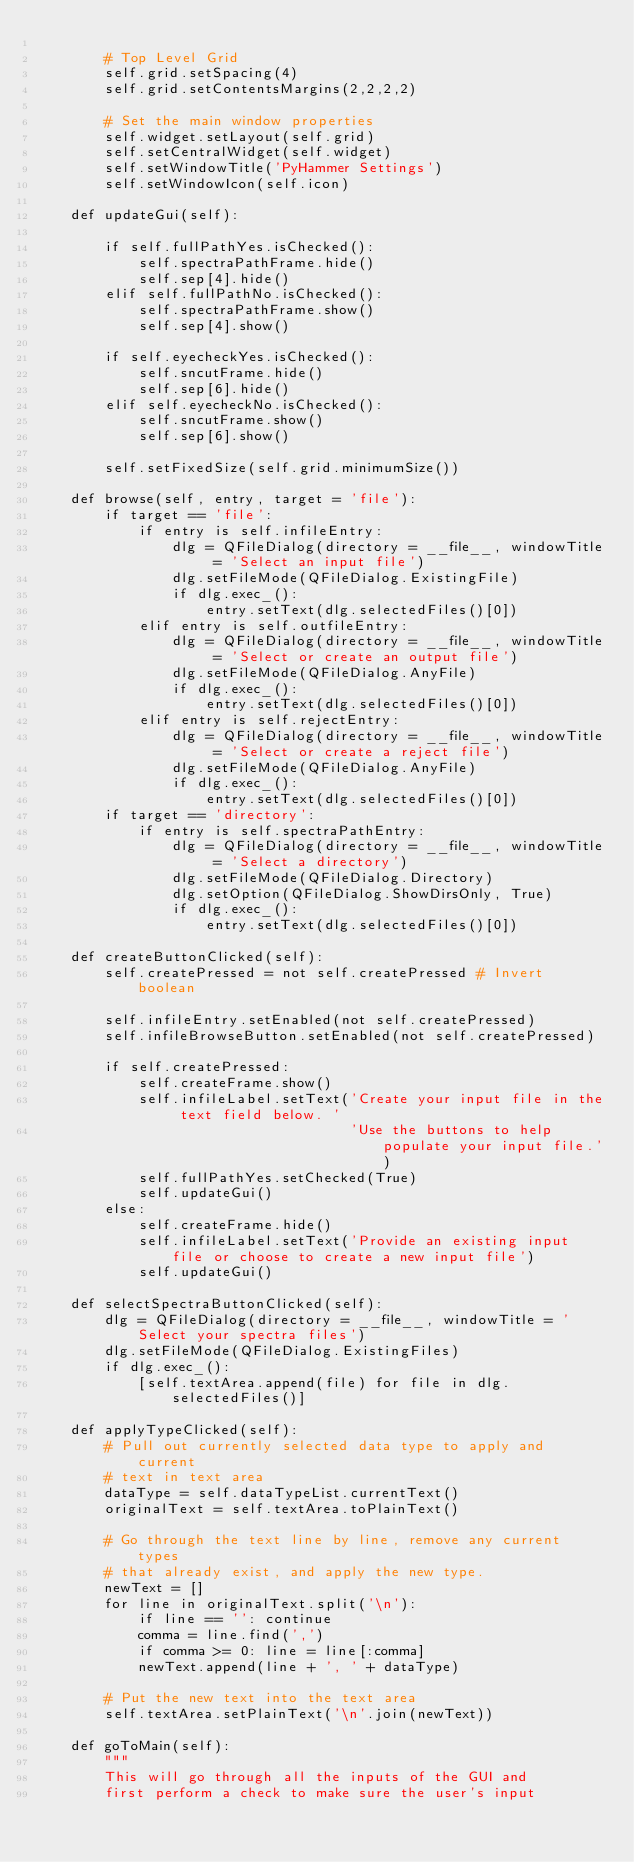Convert code to text. <code><loc_0><loc_0><loc_500><loc_500><_Python_>
        # Top Level Grid
        self.grid.setSpacing(4)
        self.grid.setContentsMargins(2,2,2,2)

        # Set the main window properties
        self.widget.setLayout(self.grid)
        self.setCentralWidget(self.widget)
        self.setWindowTitle('PyHammer Settings')
        self.setWindowIcon(self.icon)

    def updateGui(self):

        if self.fullPathYes.isChecked():
            self.spectraPathFrame.hide()
            self.sep[4].hide()
        elif self.fullPathNo.isChecked():
            self.spectraPathFrame.show()
            self.sep[4].show()

        if self.eyecheckYes.isChecked():
            self.sncutFrame.hide()
            self.sep[6].hide()
        elif self.eyecheckNo.isChecked():
            self.sncutFrame.show()
            self.sep[6].show()
           
        self.setFixedSize(self.grid.minimumSize())

    def browse(self, entry, target = 'file'):
        if target == 'file':
            if entry is self.infileEntry:
                dlg = QFileDialog(directory = __file__, windowTitle = 'Select an input file')
                dlg.setFileMode(QFileDialog.ExistingFile)
                if dlg.exec_():
                    entry.setText(dlg.selectedFiles()[0])
            elif entry is self.outfileEntry:
                dlg = QFileDialog(directory = __file__, windowTitle = 'Select or create an output file')
                dlg.setFileMode(QFileDialog.AnyFile)
                if dlg.exec_():
                    entry.setText(dlg.selectedFiles()[0])
            elif entry is self.rejectEntry:
                dlg = QFileDialog(directory = __file__, windowTitle = 'Select or create a reject file')
                dlg.setFileMode(QFileDialog.AnyFile)
                if dlg.exec_():
                    entry.setText(dlg.selectedFiles()[0])
        if target == 'directory':
            if entry is self.spectraPathEntry:
                dlg = QFileDialog(directory = __file__, windowTitle = 'Select a directory')
                dlg.setFileMode(QFileDialog.Directory)
                dlg.setOption(QFileDialog.ShowDirsOnly, True)
                if dlg.exec_():
                    entry.setText(dlg.selectedFiles()[0])

    def createButtonClicked(self):
        self.createPressed = not self.createPressed # Invert boolean

        self.infileEntry.setEnabled(not self.createPressed)
        self.infileBrowseButton.setEnabled(not self.createPressed)

        if self.createPressed:
            self.createFrame.show()
            self.infileLabel.setText('Create your input file in the text field below. '
                                     'Use the buttons to help populate your input file.')
            self.fullPathYes.setChecked(True)
            self.updateGui()
        else:
            self.createFrame.hide()
            self.infileLabel.setText('Provide an existing input file or choose to create a new input file')
            self.updateGui()

    def selectSpectraButtonClicked(self):
        dlg = QFileDialog(directory = __file__, windowTitle = 'Select your spectra files')
        dlg.setFileMode(QFileDialog.ExistingFiles)
        if dlg.exec_():
            [self.textArea.append(file) for file in dlg.selectedFiles()]

    def applyTypeClicked(self):
        # Pull out currently selected data type to apply and current
        # text in text area
        dataType = self.dataTypeList.currentText()
        originalText = self.textArea.toPlainText()

        # Go through the text line by line, remove any current types
        # that already exist, and apply the new type.
        newText = []
        for line in originalText.split('\n'):
            if line == '': continue
            comma = line.find(',')
            if comma >= 0: line = line[:comma]
            newText.append(line + ', ' + dataType)

        # Put the new text into the text area
        self.textArea.setPlainText('\n'.join(newText))

    def goToMain(self):
        """
        This will go through all the inputs of the GUI and
        first perform a check to make sure the user's input</code> 